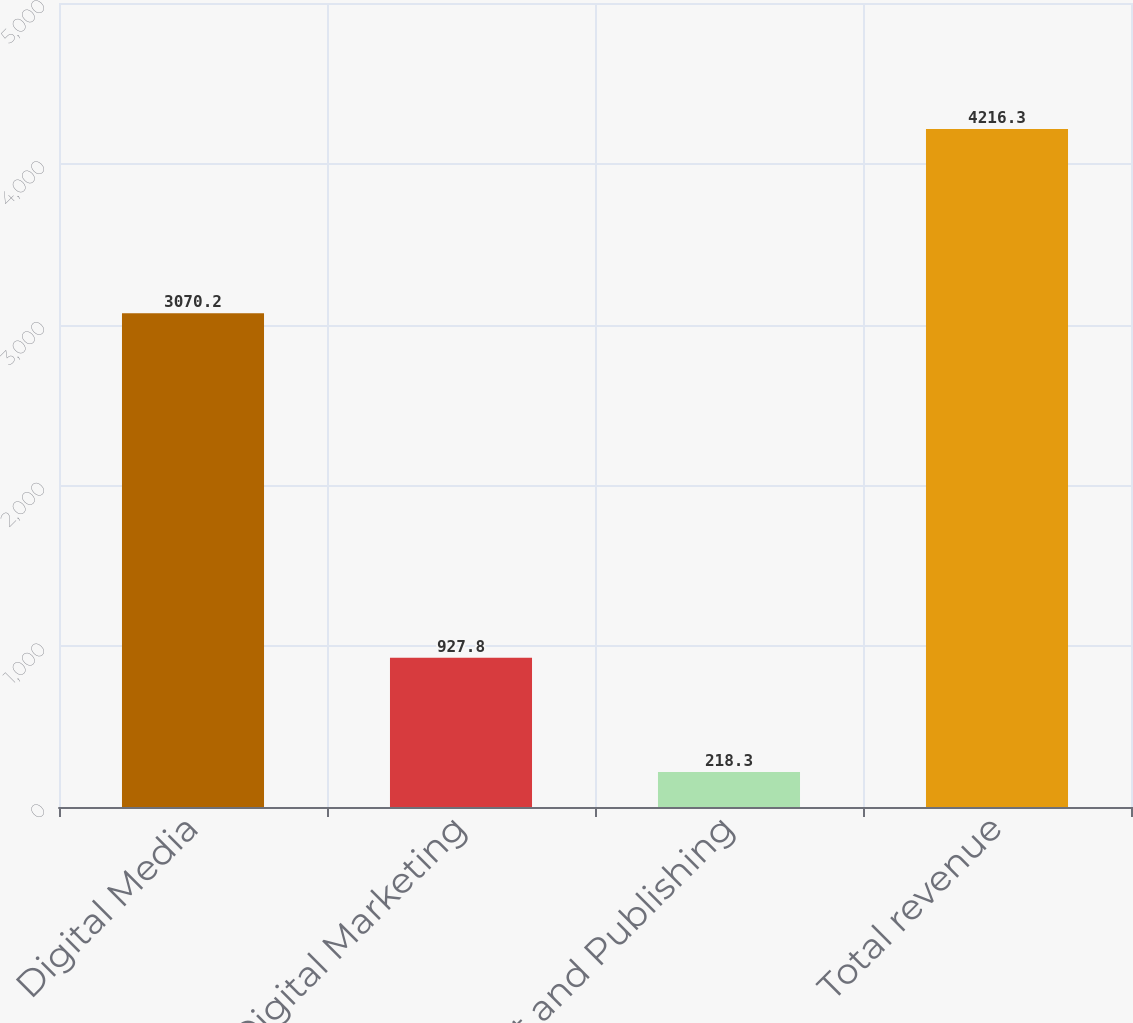<chart> <loc_0><loc_0><loc_500><loc_500><bar_chart><fcel>Digital Media<fcel>Digital Marketing<fcel>Print and Publishing<fcel>Total revenue<nl><fcel>3070.2<fcel>927.8<fcel>218.3<fcel>4216.3<nl></chart> 